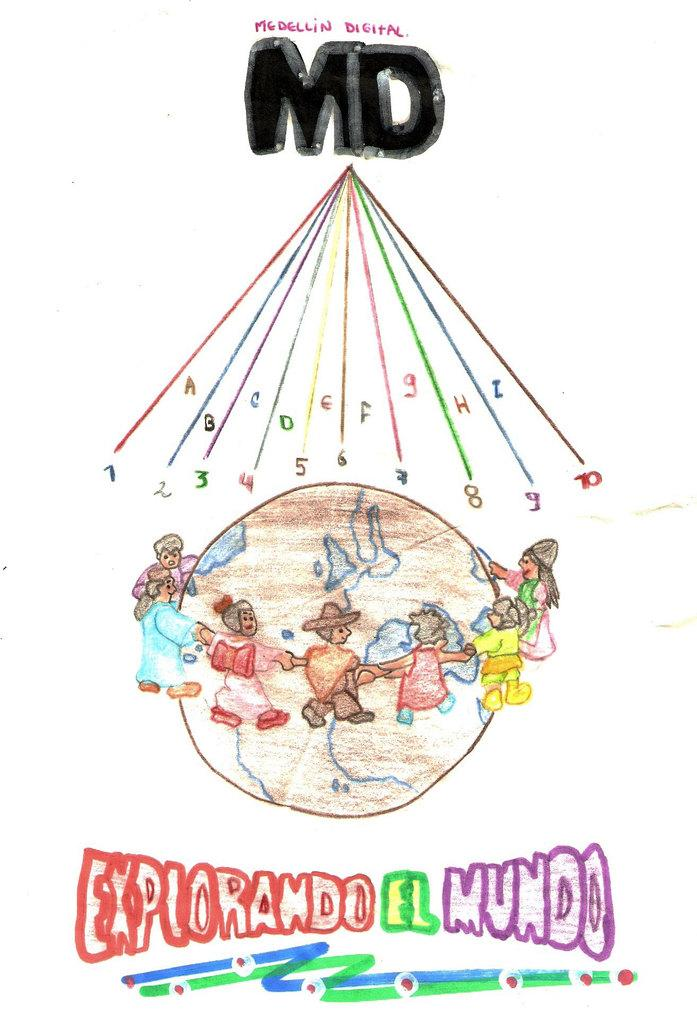Provide a one-sentence caption for the provided image. picture of explorando el mundo drawing its colorful. 